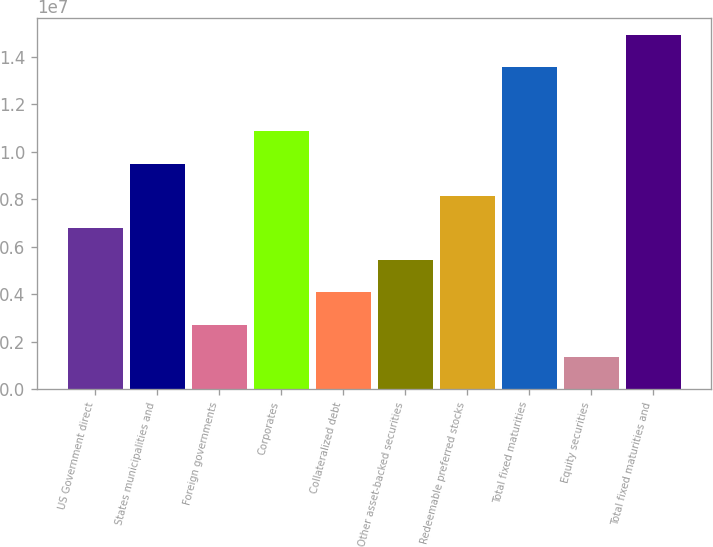<chart> <loc_0><loc_0><loc_500><loc_500><bar_chart><fcel>US Government direct<fcel>States municipalities and<fcel>Foreign governments<fcel>Corporates<fcel>Collateralized debt<fcel>Other asset-backed securities<fcel>Redeemable preferred stocks<fcel>Total fixed maturities<fcel>Equity securities<fcel>Total fixed maturities and<nl><fcel>6.77843e+06<fcel>9.48976e+06<fcel>2.71143e+06<fcel>1.08454e+07<fcel>4.0671e+06<fcel>5.42276e+06<fcel>8.1341e+06<fcel>1.35412e+07<fcel>1.35577e+06<fcel>1.48969e+07<nl></chart> 